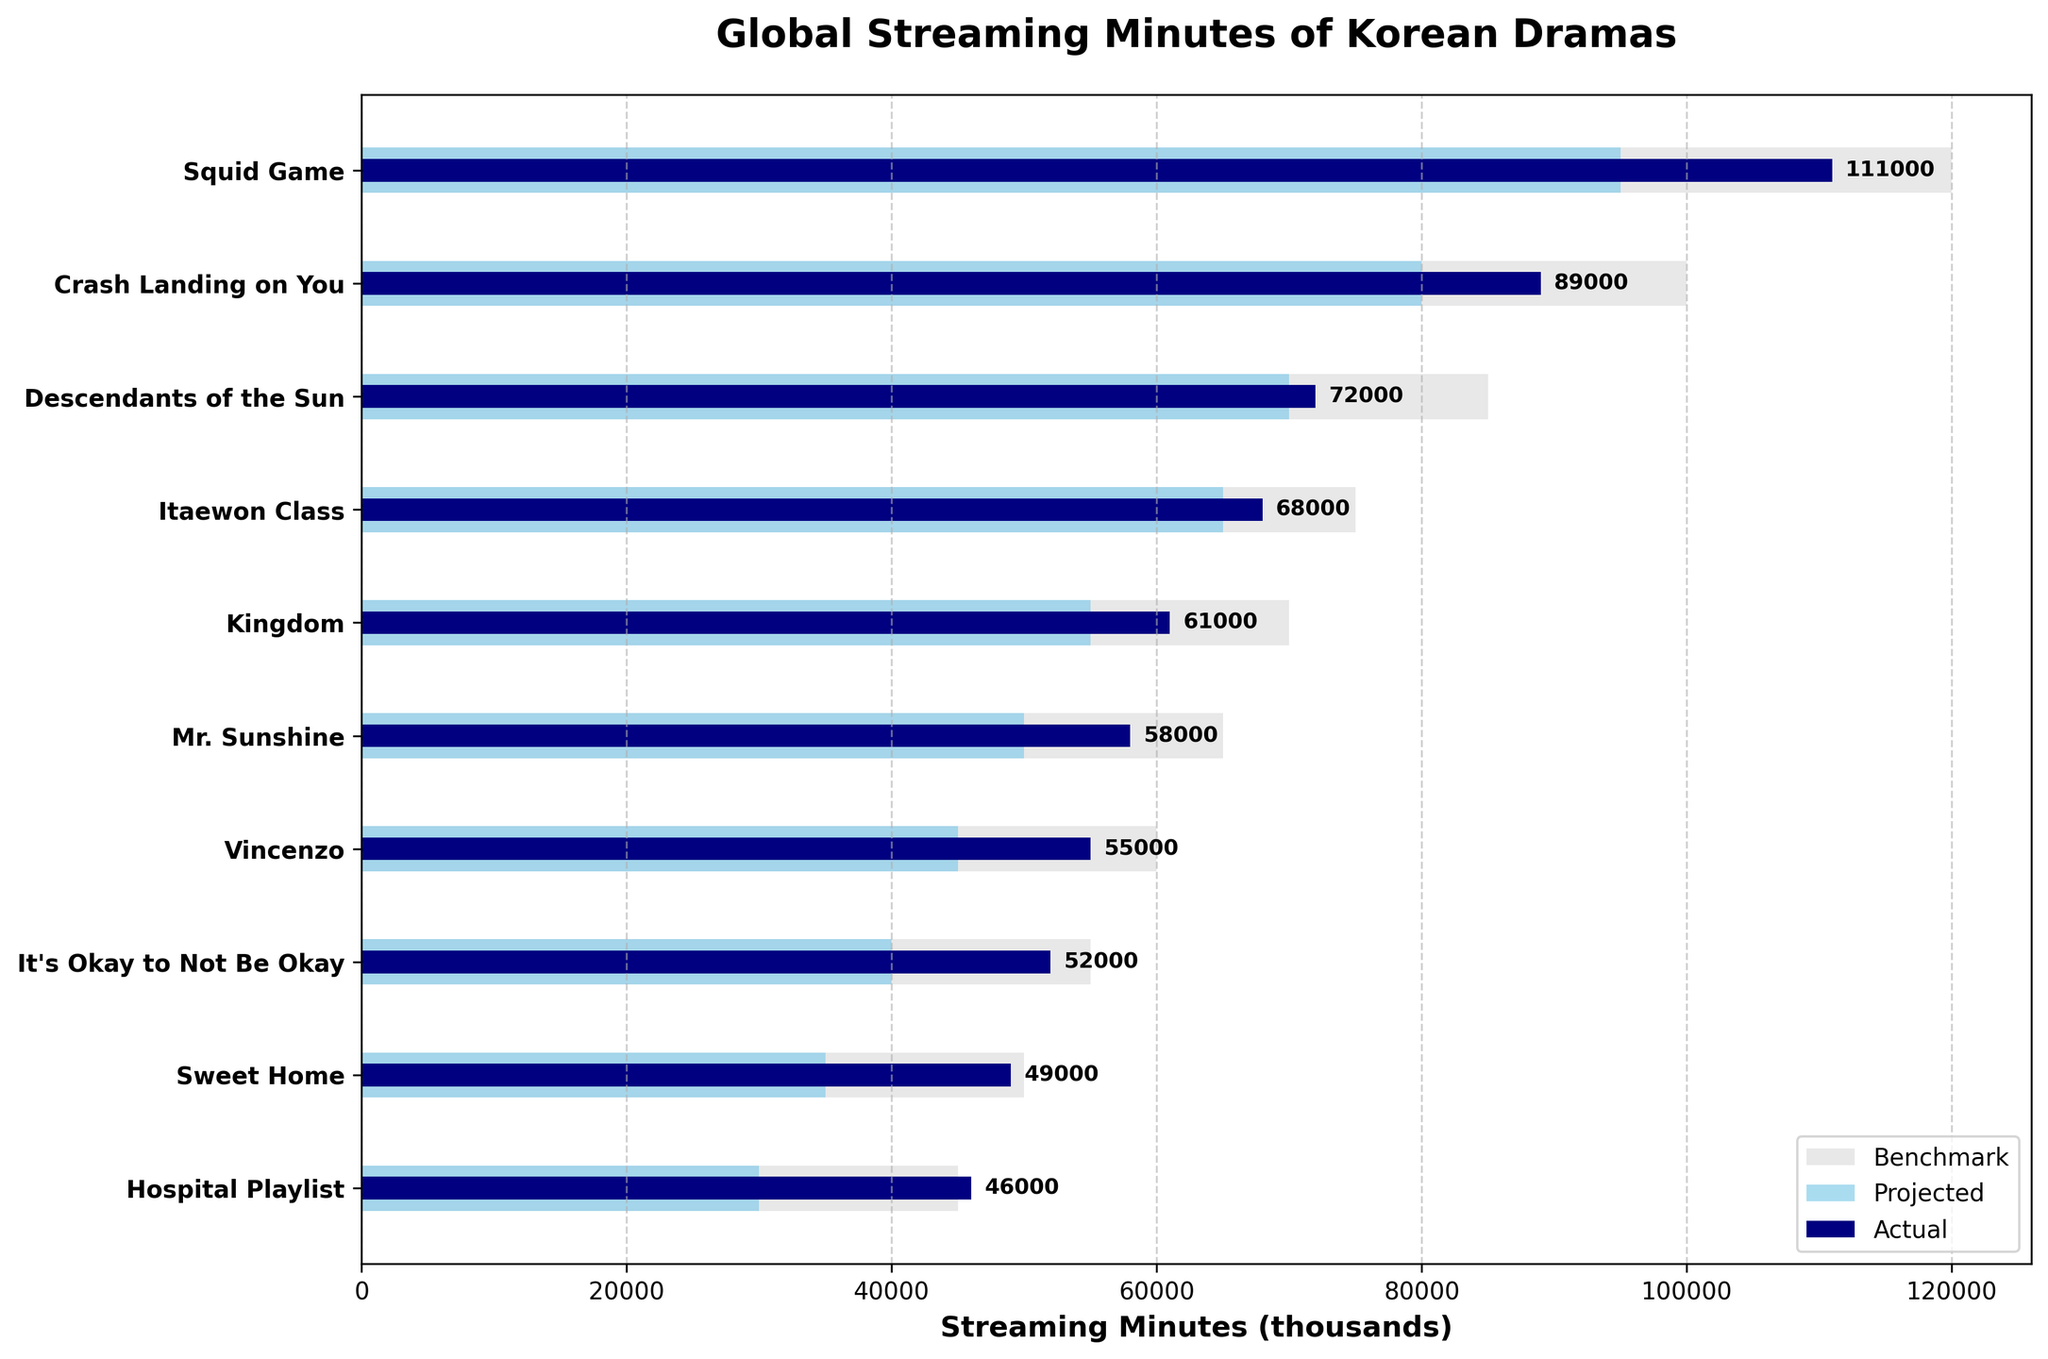1. What is the title of the figure? The title of the figure is located at the top center of the plot and is displayed in bold font.
Answer: Global Streaming Minutes of Korean Dramas 2. Which drama has the highest actual streaming minutes? By examining the actual streaming minutes bars (the darkest ones) and noting their lengths, we see that "Squid Game" has the longest bar.
Answer: Squid Game 3. How does "Crash Landing on You" compare in actual streaming minutes to its benchmark? To compare, look at the actual streaming minutes bar for "Crash Landing on You" which is 89,000 minutes, and compare it to its benchmark bar which is 100,000 minutes.
Answer: Less than benchmark 4. What are the projected streaming minutes for "Kingdom"? To determine the projected streaming minutes, locate the "Kingdom" bar with the second darkest color that corresponds to the projected streaming minutes.
Answer: 55,000 5. Which drama has a larger difference between actual and projected streaming minutes, "Vincenzo" or "Itaewon Class"? Calculate the difference for both: "Vincenzo" (55,000 - 45,000 = 10,000) and "Itaewon Class" (68,000 - 65,000 = 3,000).
Answer: Vincenzo 6. What is the average of the actual streaming minutes of "Mr. Sunshine" and "Hospital Playlist"? Compute the average by adding the actual streaming minutes of both dramas (58,000 + 46,000) and dividing by 2.
Answer: 52,000 7. Which drama was closest to its projected streaming minutes? Identify which drama has the smallest difference between actual and projected streaming minutes. "Descendants of the Sun" has the closest values (72,000 actual, 70,000 projected).
Answer: Descendants of the Sun 8. How many dramas have a benchmark higher than their actual streaming minutes? Count the number of dramas where the benchmark bar exceeds the length of the actual streaming minutes bar.
Answer: 6 9. What is the difference in actual streaming minutes between "It's Okay to Not Be Okay" and "Sweet Home"? Subtract the actual streaming minutes of "Sweet Home" from "It's Okay to Not Be Okay" (52,000 - 49,000).
Answer: 3,000 10. How do the actual streaming minutes of the top drama compare to the projected streaming minutes of the second top drama? Compare the actual streaming minutes of "Squid Game" (111,000) to the projected streaming minutes of "Crash Landing on You" (80,000).
Answer: More by 31,000 